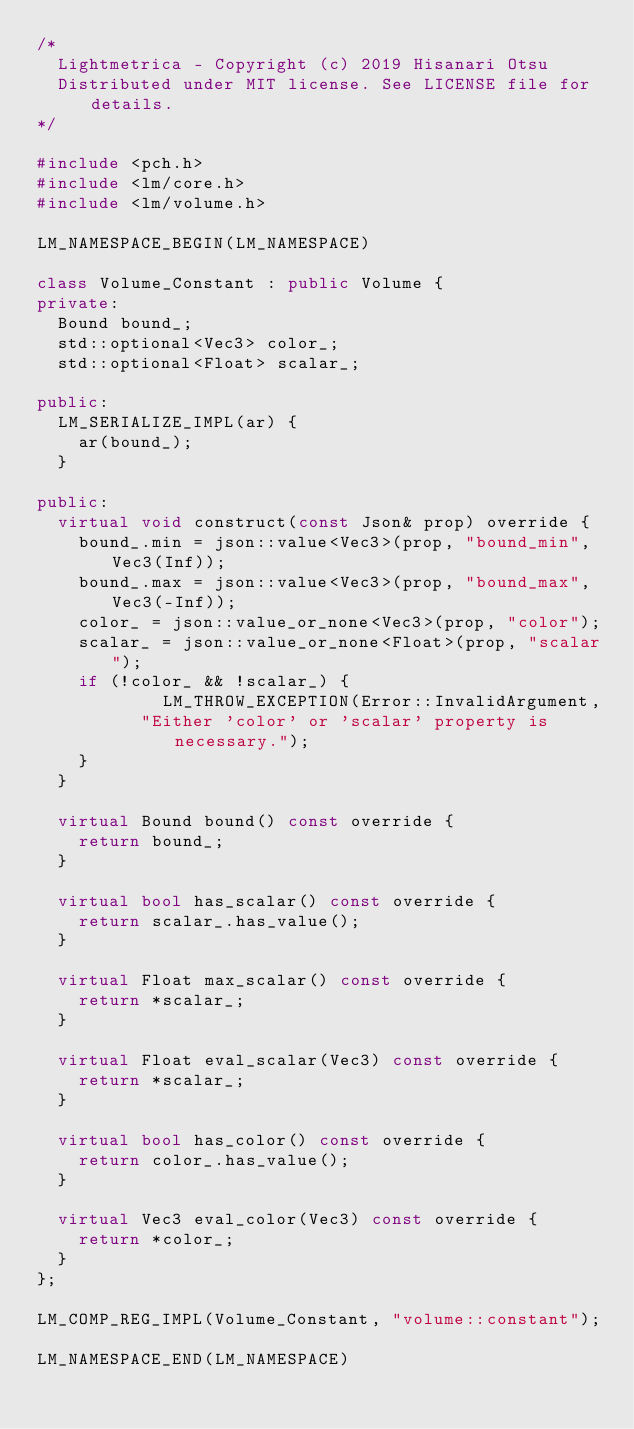<code> <loc_0><loc_0><loc_500><loc_500><_C++_>/*
	Lightmetrica - Copyright (c) 2019 Hisanari Otsu
	Distributed under MIT license. See LICENSE file for details.
*/

#include <pch.h>
#include <lm/core.h>
#include <lm/volume.h>

LM_NAMESPACE_BEGIN(LM_NAMESPACE)

class Volume_Constant : public Volume {
private:
	Bound bound_;
	std::optional<Vec3> color_;
	std::optional<Float> scalar_;

public:
	LM_SERIALIZE_IMPL(ar) {
		ar(bound_);
	}

public:
	virtual void construct(const Json& prop) override {
		bound_.min = json::value<Vec3>(prop, "bound_min", Vec3(Inf));
		bound_.max = json::value<Vec3>(prop, "bound_max", Vec3(-Inf));
		color_ = json::value_or_none<Vec3>(prop, "color");
		scalar_ = json::value_or_none<Float>(prop, "scalar");
		if (!color_ && !scalar_) {
            LM_THROW_EXCEPTION(Error::InvalidArgument,
			    "Either 'color' or 'scalar' property is necessary.");
		}
	}
	
	virtual Bound bound() const override {
		return bound_;
	}

	virtual bool has_scalar() const override {
		return scalar_.has_value();
	}

	virtual Float max_scalar() const override {
		return *scalar_;
	}

	virtual Float eval_scalar(Vec3) const override {
		return *scalar_;
	}

	virtual bool has_color() const override {
		return color_.has_value();
	}

	virtual Vec3 eval_color(Vec3) const override {
		return *color_;
	}
};

LM_COMP_REG_IMPL(Volume_Constant, "volume::constant");

LM_NAMESPACE_END(LM_NAMESPACE)
</code> 